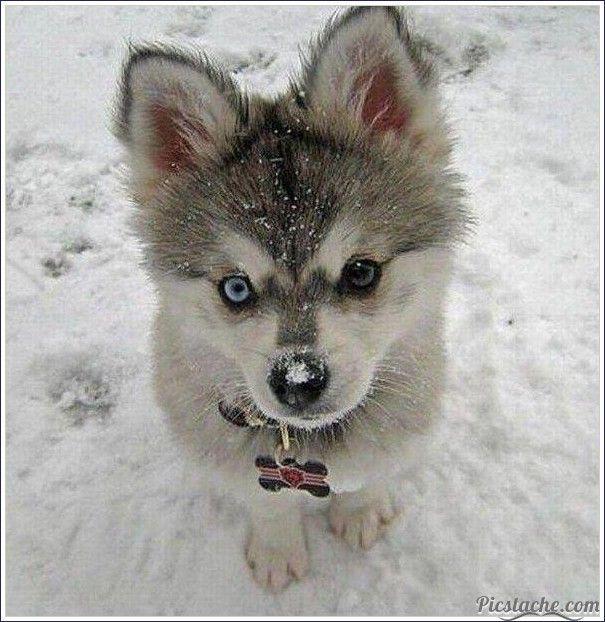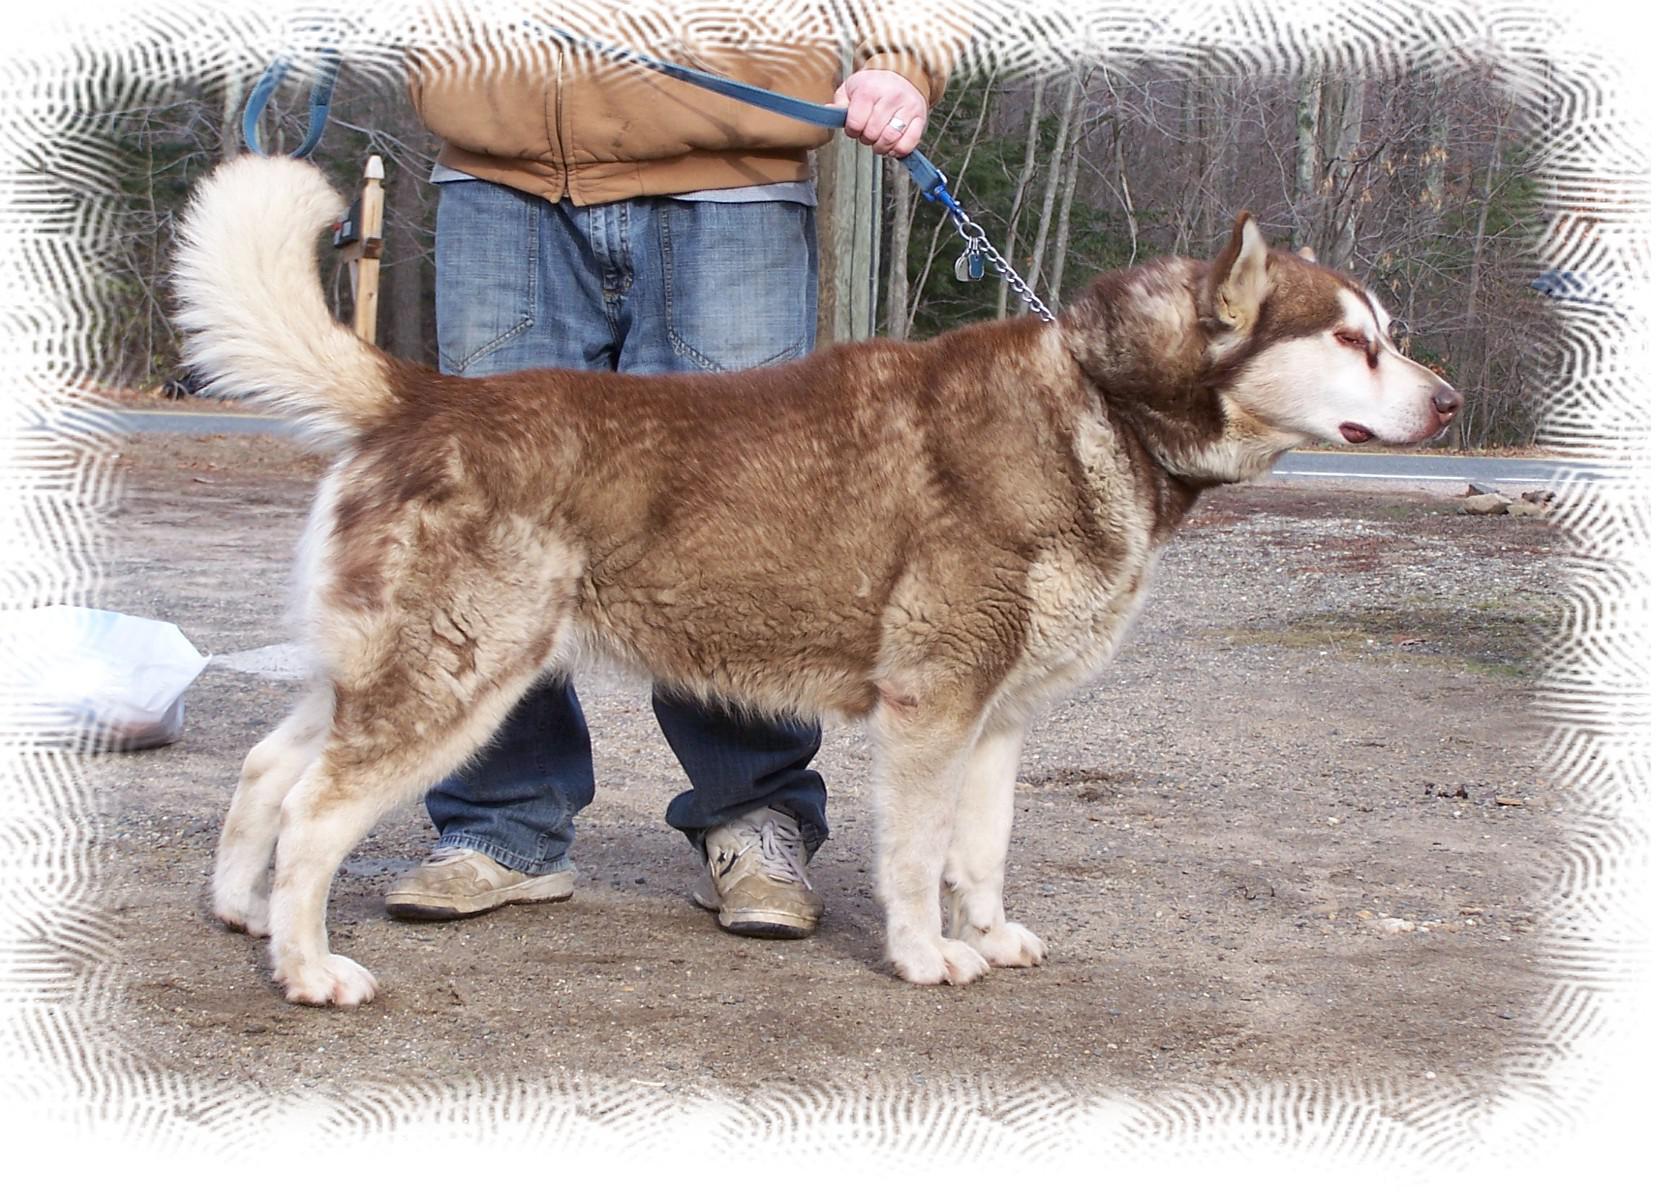The first image is the image on the left, the second image is the image on the right. Assess this claim about the two images: "The left image has exactly one dog with it's mouth closed, the right image has exactly one dog with it's tongue out.". Correct or not? Answer yes or no. No. The first image is the image on the left, the second image is the image on the right. Given the left and right images, does the statement "The right image includes a dog with its tongue hanging down, and the left image includes a leftward-facing dog with snow on its fur and its paws draped forward." hold true? Answer yes or no. No. 